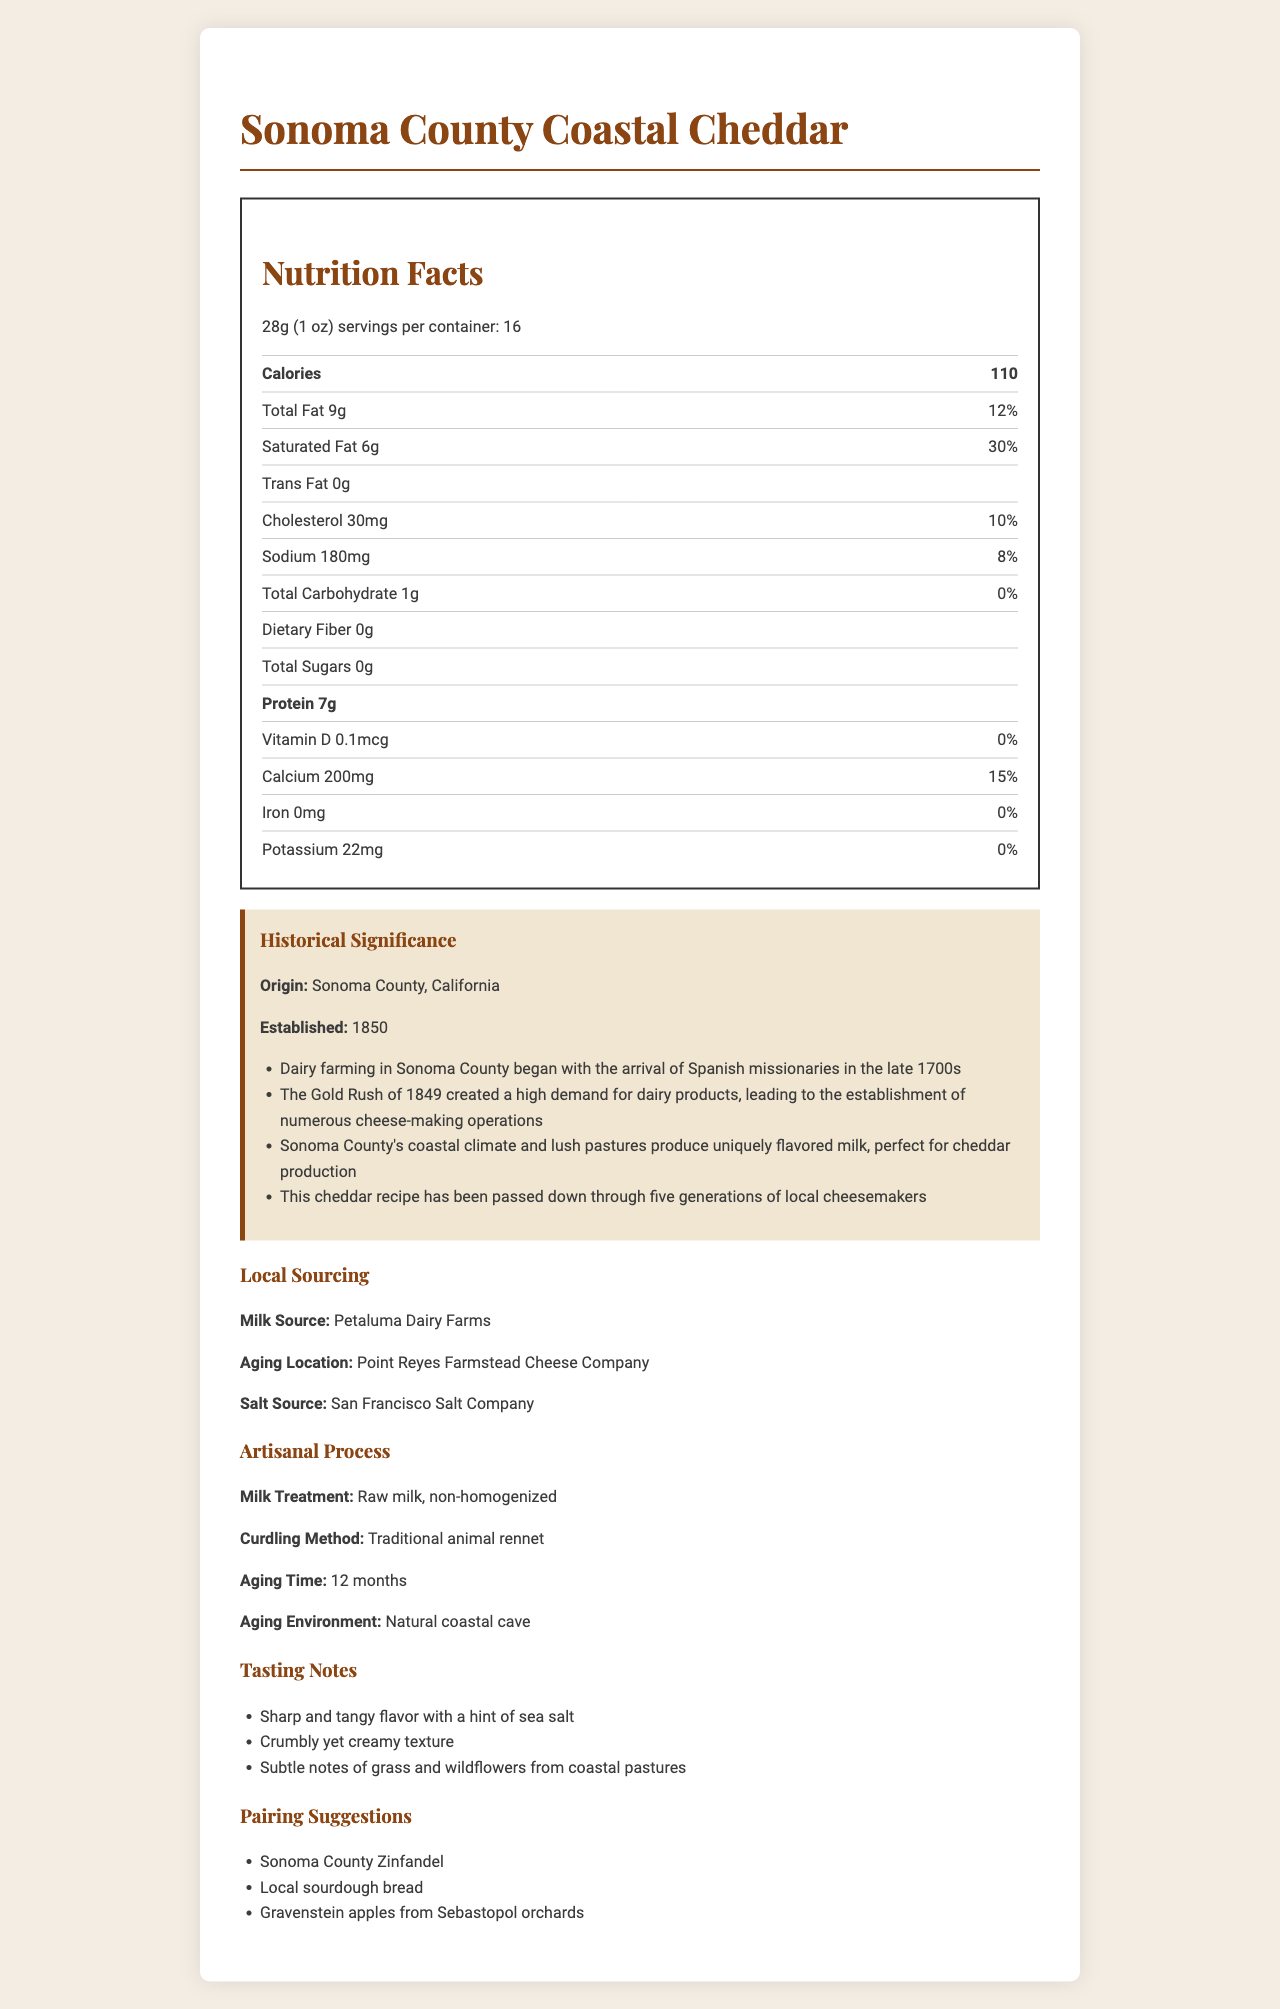what is the serving size? The serving size is clearly mentioned at the beginning of the Nutrition Facts section.
Answer: 28g (1 oz) how many calories are there per serving? The calorie count per serving is listed prominently under the serving size.
Answer: 110 what is the total fat content per serving? The total fat content is given in the Nutrition Facts section under calories.
Answer: 9g where is the milk for this cheese sourced from? The milk source is listed under Local Sourcing.
Answer: Petaluma Dairy Farms what is the aging location of the cheese? The aging location is mentioned under Local Sourcing.
Answer: Point Reyes Farmstead Cheese Company How many historical notes are listed? The document lists four historical notes in the Historical Significance section.
Answer: Four What percentage of the daily value of saturated fat does each serving provide? The daily value percentage for saturated fat is listed next to its amount in the Nutrition Facts section.
Answer: 30% where is the salt sourced from? A. Point Reyes Farmstead Cheese Company B. Petaluma Dairy Farms C. San Francisco Salt Company D. Sonoma County The salt source is clearly mentioned under Local Sourcing as San Francisco Salt Company.
Answer: C which of the following best describes the cheese's texture? A. Hard and dry B. Crumbly yet creamy C. Smooth and soft D. Sticky The tasting notes mention the cheese as "Crumbly yet creamy."
Answer: B is there any trans fat in the cheese? The amount of trans fat is listed as 0g in the Nutrition Facts section.
Answer: No what kind of milk is used in the cheese-making process? The milk treatment is mentioned under Artisanal Process.
Answer: Raw milk, non-homogenized how long is the cheese aged? The aging time is listed under Artisanal Process.
Answer: 12 months what are the tasting notes of the cheese? The tasting notes are listed in the Tasting Notes section.
Answer: Sharp and tangy flavor with a hint of sea salt, Crumbly yet creamy texture, Subtle notes of grass and wildflowers from coastal pastures when was the dairy farming establishment in Sonoma County? The year established is mentioned in the Historical Significance section.
Answer: 1850 summarize the main idea of this document The document contains various sections that detail the nutrition facts, historical background, sourcing, artisanal process, tasting notes, and recommended pairings.
Answer: This document provides comprehensive details about the Sonoma County Coastal Cheddar, including its nutrition facts, historical significance, local sourcing, artisanal process, tasting notes, and pairing suggestions. what is the sodium content per serving? The sodium content per serving is listed in the Nutrition Facts section.
Answer: 180mg can the amount of Potassium be determined from this document? The Potassium content is listed as 22mg in the Nutrition Facts section.
Answer: Yes 